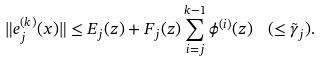Convert formula to latex. <formula><loc_0><loc_0><loc_500><loc_500>\| e ^ { ( k ) } _ { j } ( x ) \| \leq E _ { j } ( z ) + F _ { j } ( z ) \sum _ { i = j } ^ { k - 1 } \phi ^ { ( i ) } ( z ) \ \ ( \leq \tilde { \gamma } _ { j } ) .</formula> 